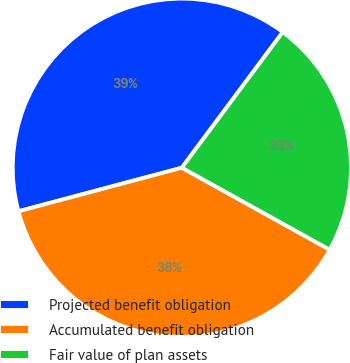<chart> <loc_0><loc_0><loc_500><loc_500><pie_chart><fcel>Projected benefit obligation<fcel>Accumulated benefit obligation<fcel>Fair value of plan assets<nl><fcel>39.33%<fcel>37.8%<fcel>22.88%<nl></chart> 